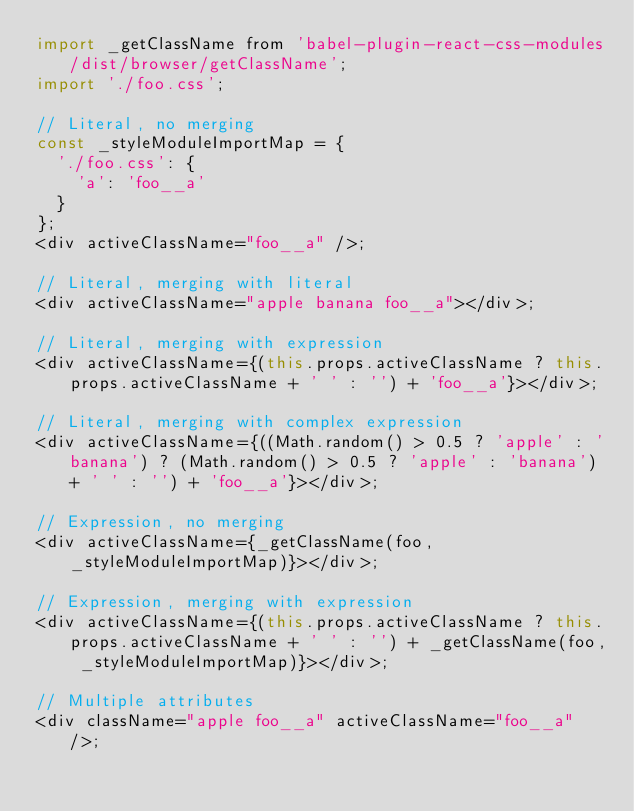<code> <loc_0><loc_0><loc_500><loc_500><_JavaScript_>import _getClassName from 'babel-plugin-react-css-modules/dist/browser/getClassName';
import './foo.css';

// Literal, no merging
const _styleModuleImportMap = {
  './foo.css': {
    'a': 'foo__a'
  }
};
<div activeClassName="foo__a" />;

// Literal, merging with literal
<div activeClassName="apple banana foo__a"></div>;

// Literal, merging with expression
<div activeClassName={(this.props.activeClassName ? this.props.activeClassName + ' ' : '') + 'foo__a'}></div>;

// Literal, merging with complex expression
<div activeClassName={((Math.random() > 0.5 ? 'apple' : 'banana') ? (Math.random() > 0.5 ? 'apple' : 'banana') + ' ' : '') + 'foo__a'}></div>;

// Expression, no merging
<div activeClassName={_getClassName(foo, _styleModuleImportMap)}></div>;

// Expression, merging with expression
<div activeClassName={(this.props.activeClassName ? this.props.activeClassName + ' ' : '') + _getClassName(foo, _styleModuleImportMap)}></div>;

// Multiple attributes
<div className="apple foo__a" activeClassName="foo__a" />;
</code> 